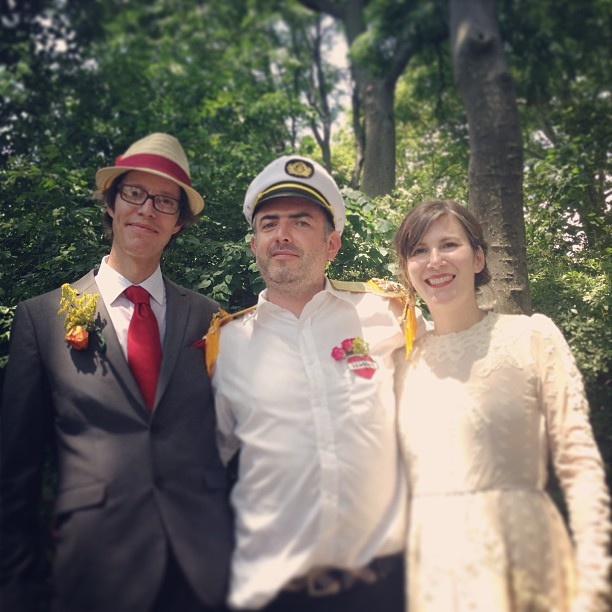Describe the objects in this image and their specific colors. I can see people in black, gray, and brown tones, people in black, lightgray, and darkgray tones, people in black, ivory, and tan tones, and tie in black, maroon, and brown tones in this image. 